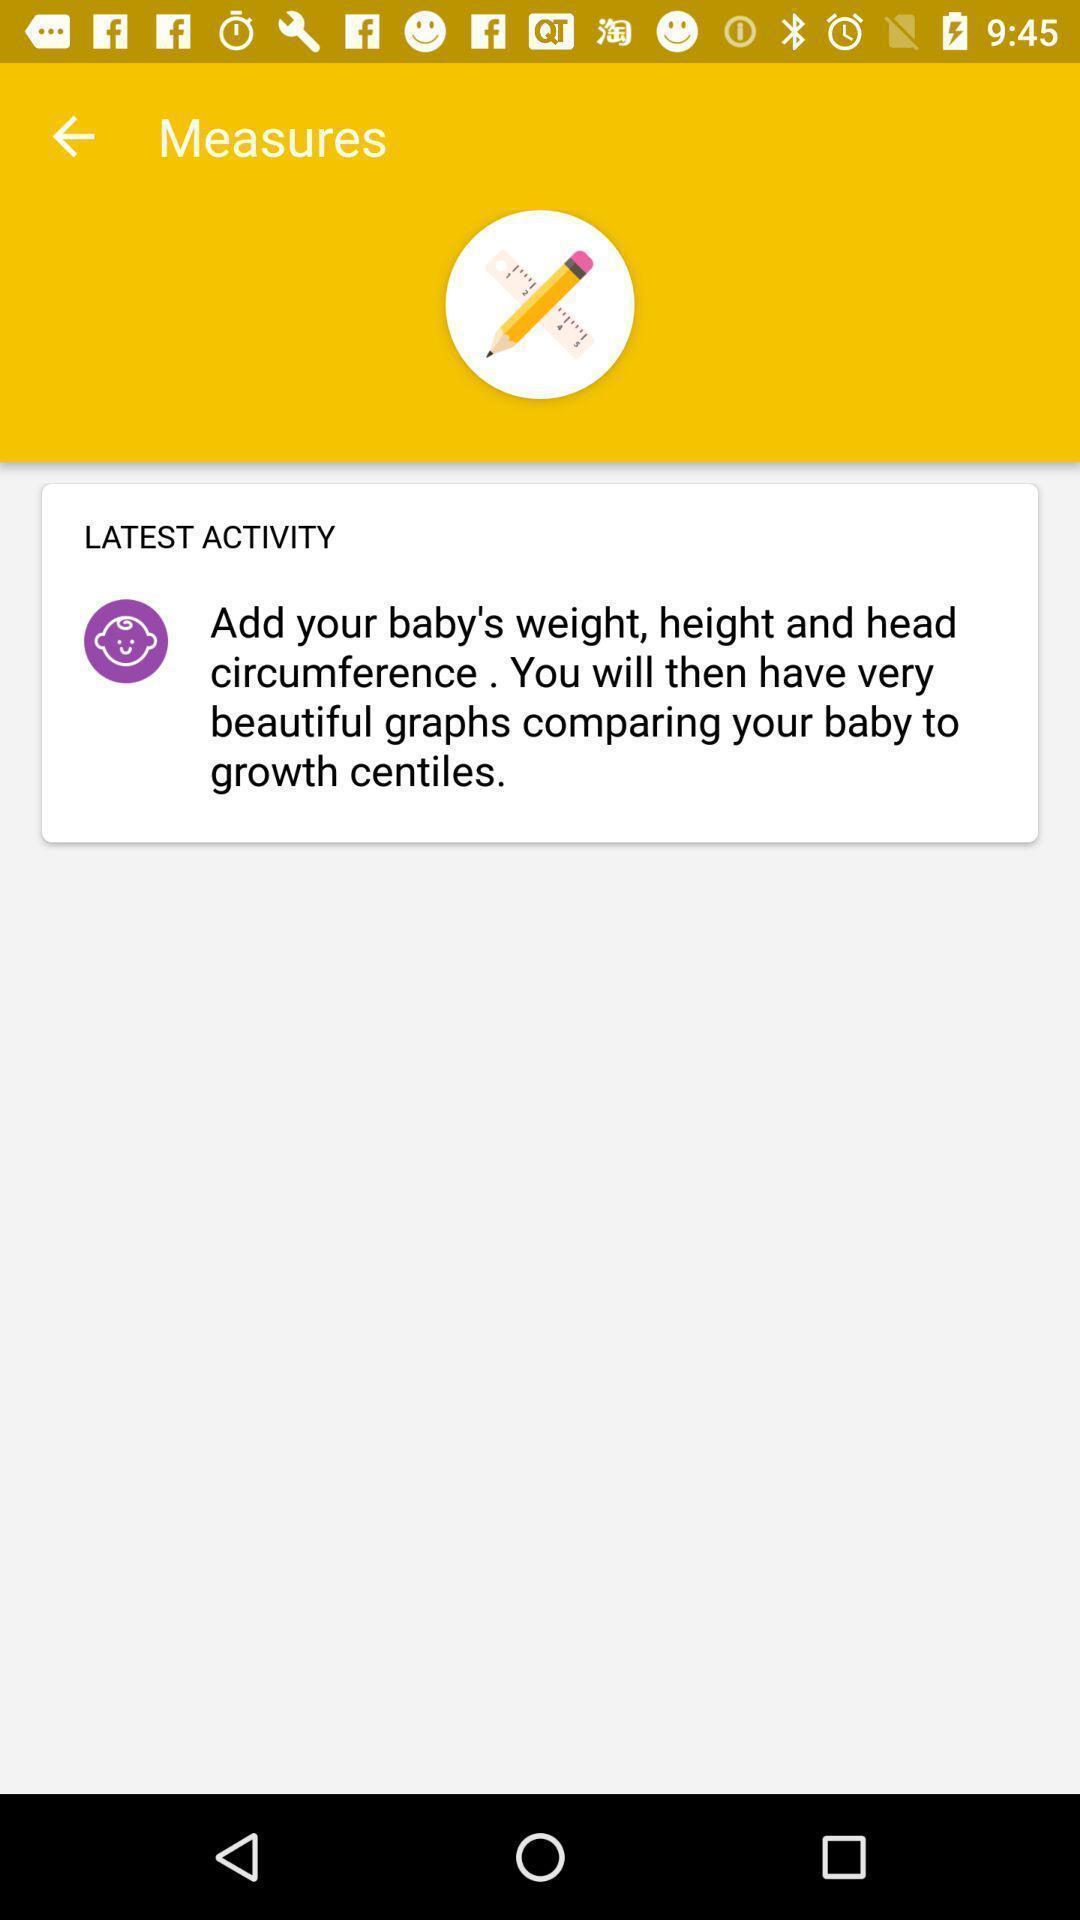Explain what's happening in this screen capture. Page of a baby manager app with an activity. 